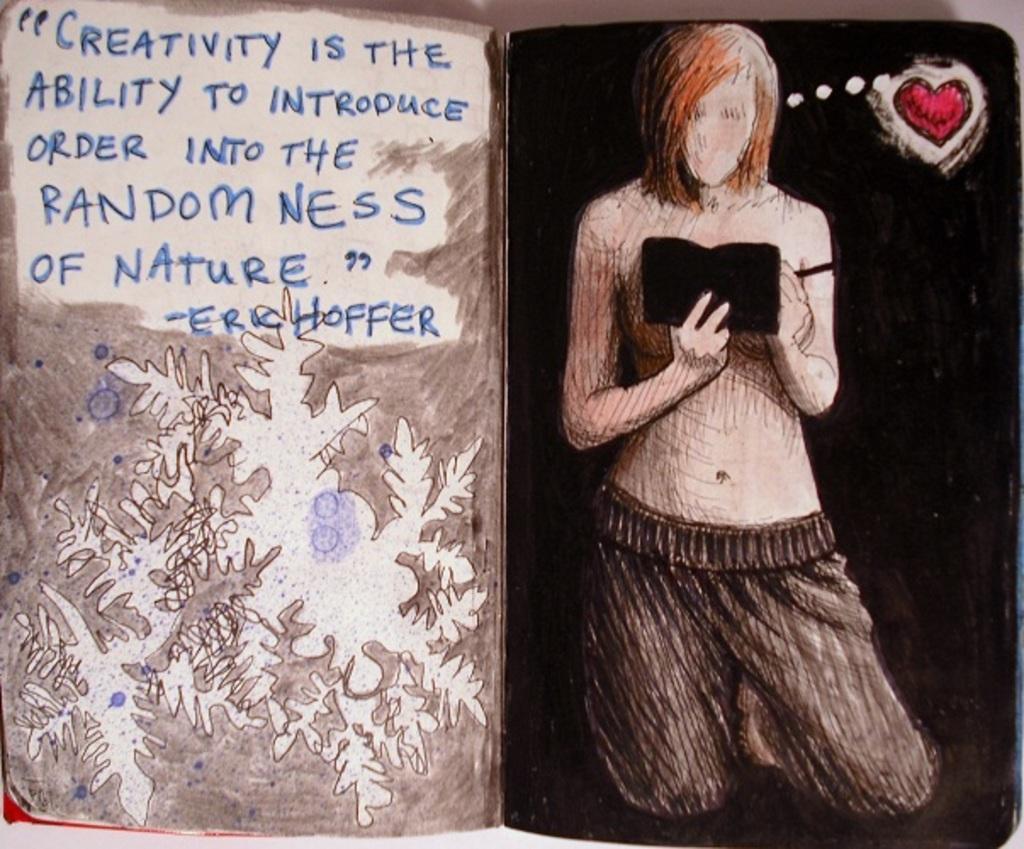How would you summarize this image in a sentence or two? In this image there is a book and we can see text and there is a picture of a man holding a book. We can see some art. 